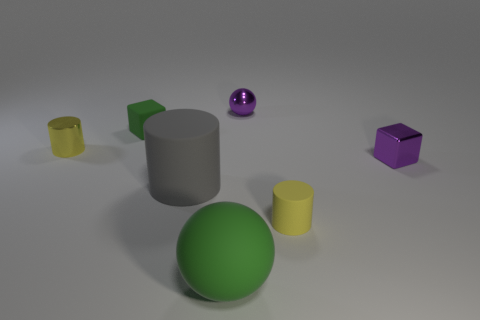Subtract all small matte cylinders. How many cylinders are left? 2 Subtract 2 cubes. How many cubes are left? 0 Subtract all gray cylinders. How many cylinders are left? 2 Subtract all blocks. How many objects are left? 5 Subtract all gray balls. Subtract all gray cubes. How many balls are left? 2 Subtract all red cylinders. How many green cubes are left? 1 Subtract all rubber blocks. Subtract all yellow rubber cylinders. How many objects are left? 5 Add 2 gray matte cylinders. How many gray matte cylinders are left? 3 Add 7 big brown matte things. How many big brown matte things exist? 7 Add 2 purple things. How many objects exist? 9 